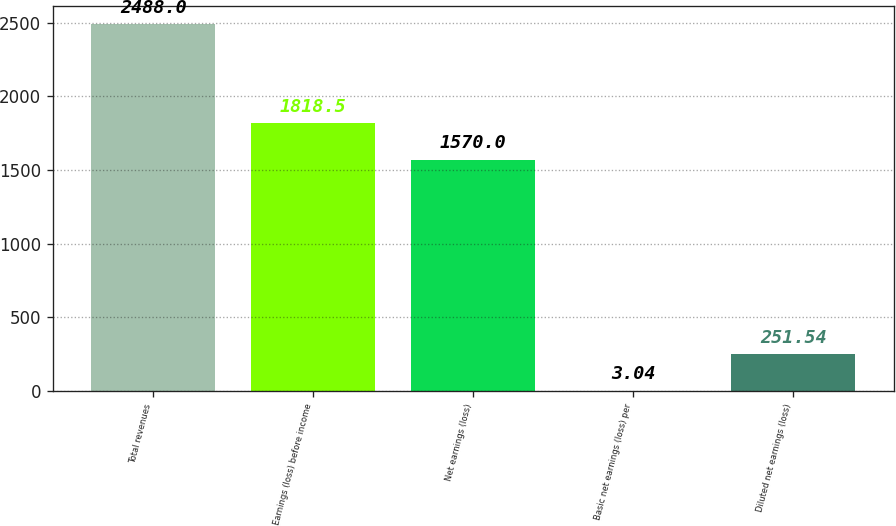Convert chart. <chart><loc_0><loc_0><loc_500><loc_500><bar_chart><fcel>Total revenues<fcel>Earnings (loss) before income<fcel>Net earnings (loss)<fcel>Basic net earnings (loss) per<fcel>Diluted net earnings (loss)<nl><fcel>2488<fcel>1818.5<fcel>1570<fcel>3.04<fcel>251.54<nl></chart> 